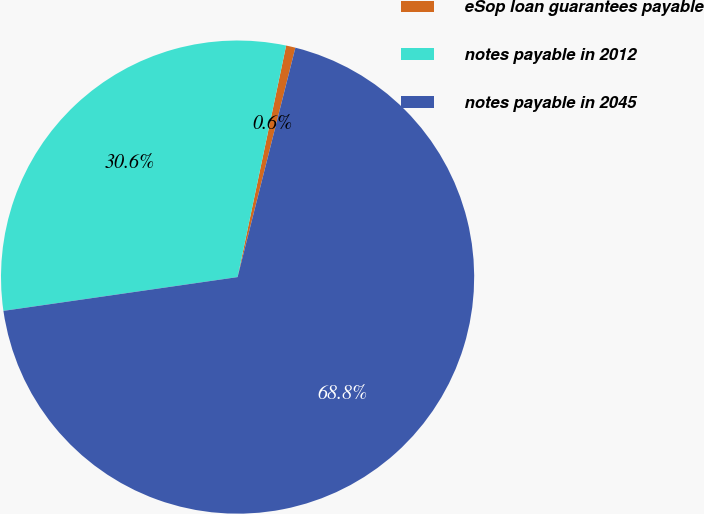Convert chart to OTSL. <chart><loc_0><loc_0><loc_500><loc_500><pie_chart><fcel>eSop loan guarantees payable<fcel>notes payable in 2012<fcel>notes payable in 2045<nl><fcel>0.64%<fcel>30.57%<fcel>68.79%<nl></chart> 